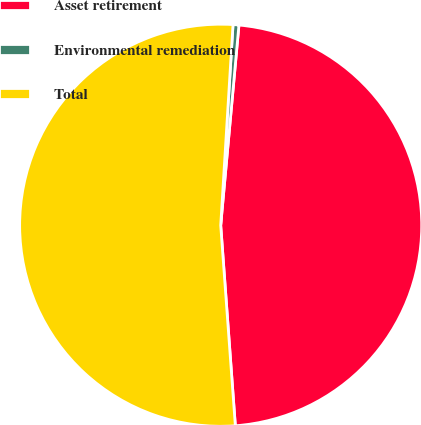Convert chart to OTSL. <chart><loc_0><loc_0><loc_500><loc_500><pie_chart><fcel>Asset retirement<fcel>Environmental remediation<fcel>Total<nl><fcel>47.39%<fcel>0.47%<fcel>52.13%<nl></chart> 